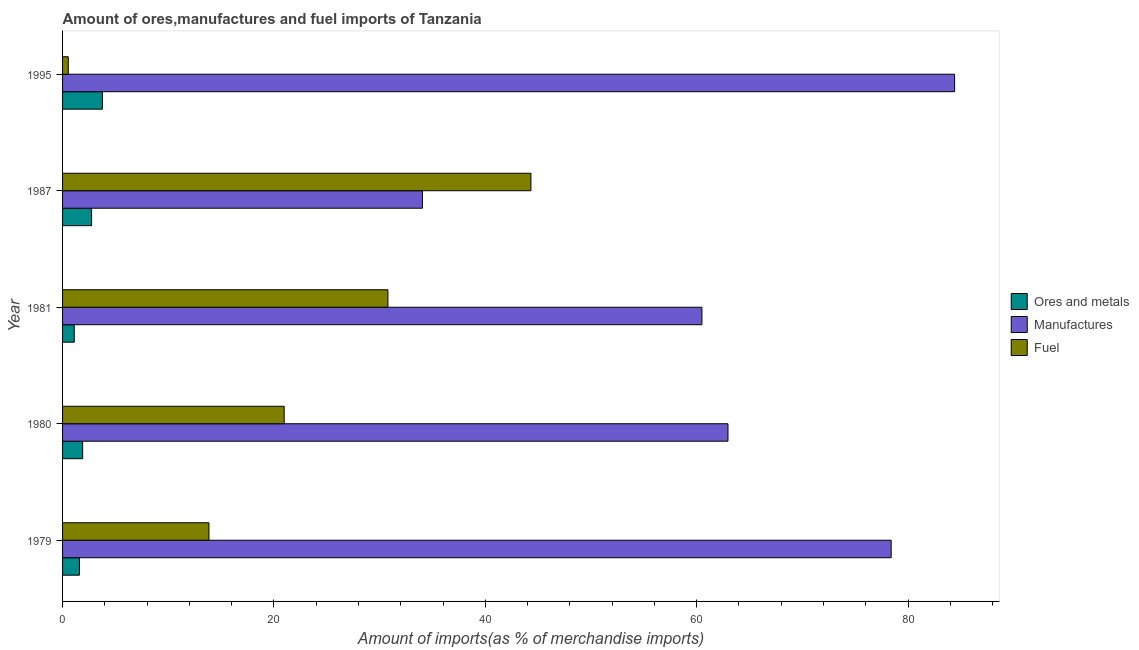How many different coloured bars are there?
Your answer should be very brief. 3. How many bars are there on the 1st tick from the top?
Your response must be concise. 3. How many bars are there on the 1st tick from the bottom?
Give a very brief answer. 3. What is the label of the 4th group of bars from the top?
Provide a succinct answer. 1980. In how many cases, is the number of bars for a given year not equal to the number of legend labels?
Offer a terse response. 0. What is the percentage of fuel imports in 1995?
Your response must be concise. 0.54. Across all years, what is the maximum percentage of ores and metals imports?
Give a very brief answer. 3.77. Across all years, what is the minimum percentage of ores and metals imports?
Provide a succinct answer. 1.11. In which year was the percentage of manufactures imports minimum?
Keep it short and to the point. 1987. What is the total percentage of fuel imports in the graph?
Ensure brevity in your answer.  110.45. What is the difference between the percentage of fuel imports in 1980 and that in 1981?
Offer a terse response. -9.81. What is the difference between the percentage of fuel imports in 1995 and the percentage of ores and metals imports in 1987?
Offer a terse response. -2.2. What is the average percentage of manufactures imports per year?
Give a very brief answer. 64.06. In the year 1987, what is the difference between the percentage of ores and metals imports and percentage of manufactures imports?
Offer a very short reply. -31.3. What is the ratio of the percentage of manufactures imports in 1981 to that in 1995?
Ensure brevity in your answer.  0.72. What is the difference between the highest and the second highest percentage of manufactures imports?
Give a very brief answer. 6. What is the difference between the highest and the lowest percentage of fuel imports?
Make the answer very short. 43.77. What does the 2nd bar from the top in 1981 represents?
Provide a short and direct response. Manufactures. What does the 2nd bar from the bottom in 1980 represents?
Your response must be concise. Manufactures. Is it the case that in every year, the sum of the percentage of ores and metals imports and percentage of manufactures imports is greater than the percentage of fuel imports?
Give a very brief answer. No. How many bars are there?
Provide a succinct answer. 15. How many years are there in the graph?
Ensure brevity in your answer.  5. What is the difference between two consecutive major ticks on the X-axis?
Provide a succinct answer. 20. Does the graph contain grids?
Provide a short and direct response. No. Where does the legend appear in the graph?
Your answer should be compact. Center right. How many legend labels are there?
Offer a terse response. 3. How are the legend labels stacked?
Offer a terse response. Vertical. What is the title of the graph?
Make the answer very short. Amount of ores,manufactures and fuel imports of Tanzania. Does "Tertiary" appear as one of the legend labels in the graph?
Offer a very short reply. No. What is the label or title of the X-axis?
Your answer should be compact. Amount of imports(as % of merchandise imports). What is the label or title of the Y-axis?
Make the answer very short. Year. What is the Amount of imports(as % of merchandise imports) of Ores and metals in 1979?
Keep it short and to the point. 1.59. What is the Amount of imports(as % of merchandise imports) in Manufactures in 1979?
Ensure brevity in your answer.  78.4. What is the Amount of imports(as % of merchandise imports) in Fuel in 1979?
Offer a terse response. 13.85. What is the Amount of imports(as % of merchandise imports) of Ores and metals in 1980?
Your answer should be very brief. 1.9. What is the Amount of imports(as % of merchandise imports) of Manufactures in 1980?
Give a very brief answer. 62.96. What is the Amount of imports(as % of merchandise imports) in Fuel in 1980?
Provide a succinct answer. 20.97. What is the Amount of imports(as % of merchandise imports) in Ores and metals in 1981?
Offer a terse response. 1.11. What is the Amount of imports(as % of merchandise imports) in Manufactures in 1981?
Provide a succinct answer. 60.49. What is the Amount of imports(as % of merchandise imports) in Fuel in 1981?
Offer a very short reply. 30.78. What is the Amount of imports(as % of merchandise imports) of Ores and metals in 1987?
Make the answer very short. 2.74. What is the Amount of imports(as % of merchandise imports) of Manufactures in 1987?
Provide a short and direct response. 34.05. What is the Amount of imports(as % of merchandise imports) of Fuel in 1987?
Keep it short and to the point. 44.31. What is the Amount of imports(as % of merchandise imports) in Ores and metals in 1995?
Make the answer very short. 3.77. What is the Amount of imports(as % of merchandise imports) of Manufactures in 1995?
Offer a very short reply. 84.4. What is the Amount of imports(as % of merchandise imports) in Fuel in 1995?
Offer a very short reply. 0.54. Across all years, what is the maximum Amount of imports(as % of merchandise imports) of Ores and metals?
Offer a terse response. 3.77. Across all years, what is the maximum Amount of imports(as % of merchandise imports) in Manufactures?
Offer a very short reply. 84.4. Across all years, what is the maximum Amount of imports(as % of merchandise imports) in Fuel?
Your answer should be compact. 44.31. Across all years, what is the minimum Amount of imports(as % of merchandise imports) in Ores and metals?
Offer a terse response. 1.11. Across all years, what is the minimum Amount of imports(as % of merchandise imports) in Manufactures?
Your answer should be compact. 34.05. Across all years, what is the minimum Amount of imports(as % of merchandise imports) in Fuel?
Provide a short and direct response. 0.54. What is the total Amount of imports(as % of merchandise imports) of Ores and metals in the graph?
Provide a succinct answer. 11.11. What is the total Amount of imports(as % of merchandise imports) in Manufactures in the graph?
Ensure brevity in your answer.  320.3. What is the total Amount of imports(as % of merchandise imports) of Fuel in the graph?
Provide a short and direct response. 110.45. What is the difference between the Amount of imports(as % of merchandise imports) in Ores and metals in 1979 and that in 1980?
Ensure brevity in your answer.  -0.31. What is the difference between the Amount of imports(as % of merchandise imports) in Manufactures in 1979 and that in 1980?
Give a very brief answer. 15.44. What is the difference between the Amount of imports(as % of merchandise imports) of Fuel in 1979 and that in 1980?
Keep it short and to the point. -7.12. What is the difference between the Amount of imports(as % of merchandise imports) in Ores and metals in 1979 and that in 1981?
Your answer should be compact. 0.49. What is the difference between the Amount of imports(as % of merchandise imports) in Manufactures in 1979 and that in 1981?
Offer a terse response. 17.9. What is the difference between the Amount of imports(as % of merchandise imports) in Fuel in 1979 and that in 1981?
Provide a short and direct response. -16.93. What is the difference between the Amount of imports(as % of merchandise imports) of Ores and metals in 1979 and that in 1987?
Your response must be concise. -1.15. What is the difference between the Amount of imports(as % of merchandise imports) in Manufactures in 1979 and that in 1987?
Your response must be concise. 44.35. What is the difference between the Amount of imports(as % of merchandise imports) in Fuel in 1979 and that in 1987?
Provide a succinct answer. -30.46. What is the difference between the Amount of imports(as % of merchandise imports) in Ores and metals in 1979 and that in 1995?
Offer a very short reply. -2.17. What is the difference between the Amount of imports(as % of merchandise imports) in Manufactures in 1979 and that in 1995?
Provide a succinct answer. -6. What is the difference between the Amount of imports(as % of merchandise imports) in Fuel in 1979 and that in 1995?
Ensure brevity in your answer.  13.31. What is the difference between the Amount of imports(as % of merchandise imports) in Ores and metals in 1980 and that in 1981?
Give a very brief answer. 0.8. What is the difference between the Amount of imports(as % of merchandise imports) of Manufactures in 1980 and that in 1981?
Ensure brevity in your answer.  2.47. What is the difference between the Amount of imports(as % of merchandise imports) in Fuel in 1980 and that in 1981?
Provide a short and direct response. -9.81. What is the difference between the Amount of imports(as % of merchandise imports) of Ores and metals in 1980 and that in 1987?
Your answer should be very brief. -0.84. What is the difference between the Amount of imports(as % of merchandise imports) in Manufactures in 1980 and that in 1987?
Provide a succinct answer. 28.91. What is the difference between the Amount of imports(as % of merchandise imports) in Fuel in 1980 and that in 1987?
Make the answer very short. -23.34. What is the difference between the Amount of imports(as % of merchandise imports) of Ores and metals in 1980 and that in 1995?
Give a very brief answer. -1.87. What is the difference between the Amount of imports(as % of merchandise imports) of Manufactures in 1980 and that in 1995?
Keep it short and to the point. -21.44. What is the difference between the Amount of imports(as % of merchandise imports) of Fuel in 1980 and that in 1995?
Give a very brief answer. 20.43. What is the difference between the Amount of imports(as % of merchandise imports) in Ores and metals in 1981 and that in 1987?
Keep it short and to the point. -1.64. What is the difference between the Amount of imports(as % of merchandise imports) in Manufactures in 1981 and that in 1987?
Your answer should be very brief. 26.45. What is the difference between the Amount of imports(as % of merchandise imports) of Fuel in 1981 and that in 1987?
Offer a terse response. -13.53. What is the difference between the Amount of imports(as % of merchandise imports) of Ores and metals in 1981 and that in 1995?
Make the answer very short. -2.66. What is the difference between the Amount of imports(as % of merchandise imports) of Manufactures in 1981 and that in 1995?
Make the answer very short. -23.91. What is the difference between the Amount of imports(as % of merchandise imports) of Fuel in 1981 and that in 1995?
Keep it short and to the point. 30.24. What is the difference between the Amount of imports(as % of merchandise imports) in Ores and metals in 1987 and that in 1995?
Offer a very short reply. -1.02. What is the difference between the Amount of imports(as % of merchandise imports) of Manufactures in 1987 and that in 1995?
Ensure brevity in your answer.  -50.35. What is the difference between the Amount of imports(as % of merchandise imports) of Fuel in 1987 and that in 1995?
Give a very brief answer. 43.77. What is the difference between the Amount of imports(as % of merchandise imports) in Ores and metals in 1979 and the Amount of imports(as % of merchandise imports) in Manufactures in 1980?
Make the answer very short. -61.37. What is the difference between the Amount of imports(as % of merchandise imports) in Ores and metals in 1979 and the Amount of imports(as % of merchandise imports) in Fuel in 1980?
Ensure brevity in your answer.  -19.37. What is the difference between the Amount of imports(as % of merchandise imports) in Manufactures in 1979 and the Amount of imports(as % of merchandise imports) in Fuel in 1980?
Give a very brief answer. 57.43. What is the difference between the Amount of imports(as % of merchandise imports) of Ores and metals in 1979 and the Amount of imports(as % of merchandise imports) of Manufactures in 1981?
Make the answer very short. -58.9. What is the difference between the Amount of imports(as % of merchandise imports) in Ores and metals in 1979 and the Amount of imports(as % of merchandise imports) in Fuel in 1981?
Provide a succinct answer. -29.19. What is the difference between the Amount of imports(as % of merchandise imports) in Manufactures in 1979 and the Amount of imports(as % of merchandise imports) in Fuel in 1981?
Offer a very short reply. 47.62. What is the difference between the Amount of imports(as % of merchandise imports) of Ores and metals in 1979 and the Amount of imports(as % of merchandise imports) of Manufactures in 1987?
Make the answer very short. -32.45. What is the difference between the Amount of imports(as % of merchandise imports) of Ores and metals in 1979 and the Amount of imports(as % of merchandise imports) of Fuel in 1987?
Provide a succinct answer. -42.72. What is the difference between the Amount of imports(as % of merchandise imports) in Manufactures in 1979 and the Amount of imports(as % of merchandise imports) in Fuel in 1987?
Ensure brevity in your answer.  34.08. What is the difference between the Amount of imports(as % of merchandise imports) in Ores and metals in 1979 and the Amount of imports(as % of merchandise imports) in Manufactures in 1995?
Provide a succinct answer. -82.81. What is the difference between the Amount of imports(as % of merchandise imports) in Ores and metals in 1979 and the Amount of imports(as % of merchandise imports) in Fuel in 1995?
Make the answer very short. 1.05. What is the difference between the Amount of imports(as % of merchandise imports) in Manufactures in 1979 and the Amount of imports(as % of merchandise imports) in Fuel in 1995?
Your response must be concise. 77.86. What is the difference between the Amount of imports(as % of merchandise imports) in Ores and metals in 1980 and the Amount of imports(as % of merchandise imports) in Manufactures in 1981?
Your answer should be very brief. -58.59. What is the difference between the Amount of imports(as % of merchandise imports) in Ores and metals in 1980 and the Amount of imports(as % of merchandise imports) in Fuel in 1981?
Make the answer very short. -28.88. What is the difference between the Amount of imports(as % of merchandise imports) in Manufactures in 1980 and the Amount of imports(as % of merchandise imports) in Fuel in 1981?
Make the answer very short. 32.18. What is the difference between the Amount of imports(as % of merchandise imports) of Ores and metals in 1980 and the Amount of imports(as % of merchandise imports) of Manufactures in 1987?
Your response must be concise. -32.15. What is the difference between the Amount of imports(as % of merchandise imports) in Ores and metals in 1980 and the Amount of imports(as % of merchandise imports) in Fuel in 1987?
Your answer should be very brief. -42.41. What is the difference between the Amount of imports(as % of merchandise imports) in Manufactures in 1980 and the Amount of imports(as % of merchandise imports) in Fuel in 1987?
Your answer should be very brief. 18.65. What is the difference between the Amount of imports(as % of merchandise imports) of Ores and metals in 1980 and the Amount of imports(as % of merchandise imports) of Manufactures in 1995?
Ensure brevity in your answer.  -82.5. What is the difference between the Amount of imports(as % of merchandise imports) in Ores and metals in 1980 and the Amount of imports(as % of merchandise imports) in Fuel in 1995?
Your answer should be compact. 1.36. What is the difference between the Amount of imports(as % of merchandise imports) in Manufactures in 1980 and the Amount of imports(as % of merchandise imports) in Fuel in 1995?
Provide a succinct answer. 62.42. What is the difference between the Amount of imports(as % of merchandise imports) in Ores and metals in 1981 and the Amount of imports(as % of merchandise imports) in Manufactures in 1987?
Your answer should be very brief. -32.94. What is the difference between the Amount of imports(as % of merchandise imports) of Ores and metals in 1981 and the Amount of imports(as % of merchandise imports) of Fuel in 1987?
Your answer should be very brief. -43.21. What is the difference between the Amount of imports(as % of merchandise imports) of Manufactures in 1981 and the Amount of imports(as % of merchandise imports) of Fuel in 1987?
Your response must be concise. 16.18. What is the difference between the Amount of imports(as % of merchandise imports) in Ores and metals in 1981 and the Amount of imports(as % of merchandise imports) in Manufactures in 1995?
Keep it short and to the point. -83.3. What is the difference between the Amount of imports(as % of merchandise imports) in Ores and metals in 1981 and the Amount of imports(as % of merchandise imports) in Fuel in 1995?
Your answer should be compact. 0.57. What is the difference between the Amount of imports(as % of merchandise imports) in Manufactures in 1981 and the Amount of imports(as % of merchandise imports) in Fuel in 1995?
Your answer should be compact. 59.95. What is the difference between the Amount of imports(as % of merchandise imports) of Ores and metals in 1987 and the Amount of imports(as % of merchandise imports) of Manufactures in 1995?
Your answer should be very brief. -81.66. What is the difference between the Amount of imports(as % of merchandise imports) in Ores and metals in 1987 and the Amount of imports(as % of merchandise imports) in Fuel in 1995?
Provide a succinct answer. 2.2. What is the difference between the Amount of imports(as % of merchandise imports) of Manufactures in 1987 and the Amount of imports(as % of merchandise imports) of Fuel in 1995?
Offer a terse response. 33.51. What is the average Amount of imports(as % of merchandise imports) of Ores and metals per year?
Offer a terse response. 2.22. What is the average Amount of imports(as % of merchandise imports) in Manufactures per year?
Your answer should be compact. 64.06. What is the average Amount of imports(as % of merchandise imports) in Fuel per year?
Your response must be concise. 22.09. In the year 1979, what is the difference between the Amount of imports(as % of merchandise imports) in Ores and metals and Amount of imports(as % of merchandise imports) in Manufactures?
Keep it short and to the point. -76.8. In the year 1979, what is the difference between the Amount of imports(as % of merchandise imports) of Ores and metals and Amount of imports(as % of merchandise imports) of Fuel?
Ensure brevity in your answer.  -12.26. In the year 1979, what is the difference between the Amount of imports(as % of merchandise imports) of Manufactures and Amount of imports(as % of merchandise imports) of Fuel?
Offer a terse response. 64.55. In the year 1980, what is the difference between the Amount of imports(as % of merchandise imports) of Ores and metals and Amount of imports(as % of merchandise imports) of Manufactures?
Offer a terse response. -61.06. In the year 1980, what is the difference between the Amount of imports(as % of merchandise imports) in Ores and metals and Amount of imports(as % of merchandise imports) in Fuel?
Provide a short and direct response. -19.07. In the year 1980, what is the difference between the Amount of imports(as % of merchandise imports) in Manufactures and Amount of imports(as % of merchandise imports) in Fuel?
Offer a very short reply. 41.99. In the year 1981, what is the difference between the Amount of imports(as % of merchandise imports) of Ores and metals and Amount of imports(as % of merchandise imports) of Manufactures?
Make the answer very short. -59.39. In the year 1981, what is the difference between the Amount of imports(as % of merchandise imports) in Ores and metals and Amount of imports(as % of merchandise imports) in Fuel?
Your answer should be very brief. -29.68. In the year 1981, what is the difference between the Amount of imports(as % of merchandise imports) of Manufactures and Amount of imports(as % of merchandise imports) of Fuel?
Your answer should be very brief. 29.71. In the year 1987, what is the difference between the Amount of imports(as % of merchandise imports) in Ores and metals and Amount of imports(as % of merchandise imports) in Manufactures?
Your response must be concise. -31.3. In the year 1987, what is the difference between the Amount of imports(as % of merchandise imports) of Ores and metals and Amount of imports(as % of merchandise imports) of Fuel?
Provide a succinct answer. -41.57. In the year 1987, what is the difference between the Amount of imports(as % of merchandise imports) of Manufactures and Amount of imports(as % of merchandise imports) of Fuel?
Offer a very short reply. -10.27. In the year 1995, what is the difference between the Amount of imports(as % of merchandise imports) in Ores and metals and Amount of imports(as % of merchandise imports) in Manufactures?
Offer a terse response. -80.63. In the year 1995, what is the difference between the Amount of imports(as % of merchandise imports) in Ores and metals and Amount of imports(as % of merchandise imports) in Fuel?
Keep it short and to the point. 3.23. In the year 1995, what is the difference between the Amount of imports(as % of merchandise imports) of Manufactures and Amount of imports(as % of merchandise imports) of Fuel?
Give a very brief answer. 83.86. What is the ratio of the Amount of imports(as % of merchandise imports) of Ores and metals in 1979 to that in 1980?
Your response must be concise. 0.84. What is the ratio of the Amount of imports(as % of merchandise imports) of Manufactures in 1979 to that in 1980?
Ensure brevity in your answer.  1.25. What is the ratio of the Amount of imports(as % of merchandise imports) of Fuel in 1979 to that in 1980?
Give a very brief answer. 0.66. What is the ratio of the Amount of imports(as % of merchandise imports) in Ores and metals in 1979 to that in 1981?
Your answer should be compact. 1.44. What is the ratio of the Amount of imports(as % of merchandise imports) in Manufactures in 1979 to that in 1981?
Provide a succinct answer. 1.3. What is the ratio of the Amount of imports(as % of merchandise imports) of Fuel in 1979 to that in 1981?
Your response must be concise. 0.45. What is the ratio of the Amount of imports(as % of merchandise imports) of Ores and metals in 1979 to that in 1987?
Your response must be concise. 0.58. What is the ratio of the Amount of imports(as % of merchandise imports) in Manufactures in 1979 to that in 1987?
Your answer should be compact. 2.3. What is the ratio of the Amount of imports(as % of merchandise imports) in Fuel in 1979 to that in 1987?
Keep it short and to the point. 0.31. What is the ratio of the Amount of imports(as % of merchandise imports) in Ores and metals in 1979 to that in 1995?
Provide a short and direct response. 0.42. What is the ratio of the Amount of imports(as % of merchandise imports) in Manufactures in 1979 to that in 1995?
Keep it short and to the point. 0.93. What is the ratio of the Amount of imports(as % of merchandise imports) of Fuel in 1979 to that in 1995?
Offer a very short reply. 25.61. What is the ratio of the Amount of imports(as % of merchandise imports) in Ores and metals in 1980 to that in 1981?
Your answer should be compact. 1.72. What is the ratio of the Amount of imports(as % of merchandise imports) in Manufactures in 1980 to that in 1981?
Keep it short and to the point. 1.04. What is the ratio of the Amount of imports(as % of merchandise imports) of Fuel in 1980 to that in 1981?
Ensure brevity in your answer.  0.68. What is the ratio of the Amount of imports(as % of merchandise imports) in Ores and metals in 1980 to that in 1987?
Offer a terse response. 0.69. What is the ratio of the Amount of imports(as % of merchandise imports) in Manufactures in 1980 to that in 1987?
Your response must be concise. 1.85. What is the ratio of the Amount of imports(as % of merchandise imports) of Fuel in 1980 to that in 1987?
Ensure brevity in your answer.  0.47. What is the ratio of the Amount of imports(as % of merchandise imports) in Ores and metals in 1980 to that in 1995?
Provide a succinct answer. 0.5. What is the ratio of the Amount of imports(as % of merchandise imports) in Manufactures in 1980 to that in 1995?
Offer a very short reply. 0.75. What is the ratio of the Amount of imports(as % of merchandise imports) in Fuel in 1980 to that in 1995?
Provide a short and direct response. 38.78. What is the ratio of the Amount of imports(as % of merchandise imports) in Ores and metals in 1981 to that in 1987?
Keep it short and to the point. 0.4. What is the ratio of the Amount of imports(as % of merchandise imports) of Manufactures in 1981 to that in 1987?
Offer a terse response. 1.78. What is the ratio of the Amount of imports(as % of merchandise imports) of Fuel in 1981 to that in 1987?
Offer a very short reply. 0.69. What is the ratio of the Amount of imports(as % of merchandise imports) in Ores and metals in 1981 to that in 1995?
Provide a short and direct response. 0.29. What is the ratio of the Amount of imports(as % of merchandise imports) of Manufactures in 1981 to that in 1995?
Ensure brevity in your answer.  0.72. What is the ratio of the Amount of imports(as % of merchandise imports) in Fuel in 1981 to that in 1995?
Your response must be concise. 56.93. What is the ratio of the Amount of imports(as % of merchandise imports) of Ores and metals in 1987 to that in 1995?
Ensure brevity in your answer.  0.73. What is the ratio of the Amount of imports(as % of merchandise imports) in Manufactures in 1987 to that in 1995?
Make the answer very short. 0.4. What is the ratio of the Amount of imports(as % of merchandise imports) of Fuel in 1987 to that in 1995?
Give a very brief answer. 81.95. What is the difference between the highest and the second highest Amount of imports(as % of merchandise imports) in Ores and metals?
Provide a succinct answer. 1.02. What is the difference between the highest and the second highest Amount of imports(as % of merchandise imports) of Manufactures?
Make the answer very short. 6. What is the difference between the highest and the second highest Amount of imports(as % of merchandise imports) of Fuel?
Keep it short and to the point. 13.53. What is the difference between the highest and the lowest Amount of imports(as % of merchandise imports) of Ores and metals?
Your answer should be very brief. 2.66. What is the difference between the highest and the lowest Amount of imports(as % of merchandise imports) in Manufactures?
Provide a short and direct response. 50.35. What is the difference between the highest and the lowest Amount of imports(as % of merchandise imports) in Fuel?
Provide a succinct answer. 43.77. 